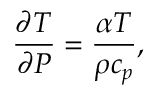<formula> <loc_0><loc_0><loc_500><loc_500>\frac { \partial T } { \partial P } = \frac { \alpha T } { \rho c _ { p } } ,</formula> 